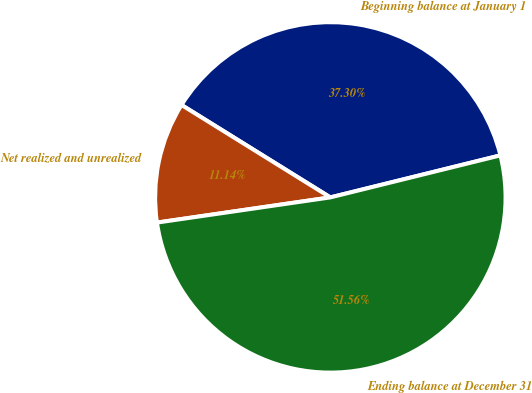Convert chart. <chart><loc_0><loc_0><loc_500><loc_500><pie_chart><fcel>Beginning balance at January 1<fcel>Net realized and unrealized<fcel>Ending balance at December 31<nl><fcel>37.3%<fcel>11.14%<fcel>51.56%<nl></chart> 